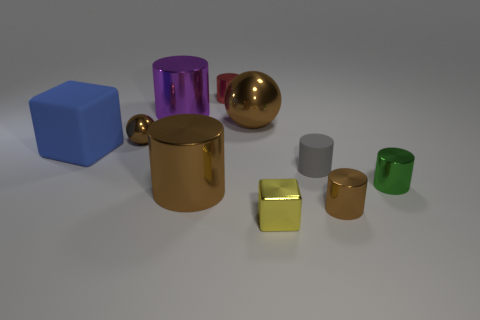Subtract all small rubber cylinders. How many cylinders are left? 5 Subtract all blue blocks. How many blocks are left? 1 Subtract all balls. How many objects are left? 8 Subtract 1 balls. How many balls are left? 1 Subtract 1 brown balls. How many objects are left? 9 Subtract all purple cylinders. Subtract all yellow balls. How many cylinders are left? 5 Subtract all cyan cubes. How many blue cylinders are left? 0 Subtract all tiny metallic balls. Subtract all small gray matte cylinders. How many objects are left? 8 Add 7 blue blocks. How many blue blocks are left? 8 Add 2 big green matte cylinders. How many big green matte cylinders exist? 2 